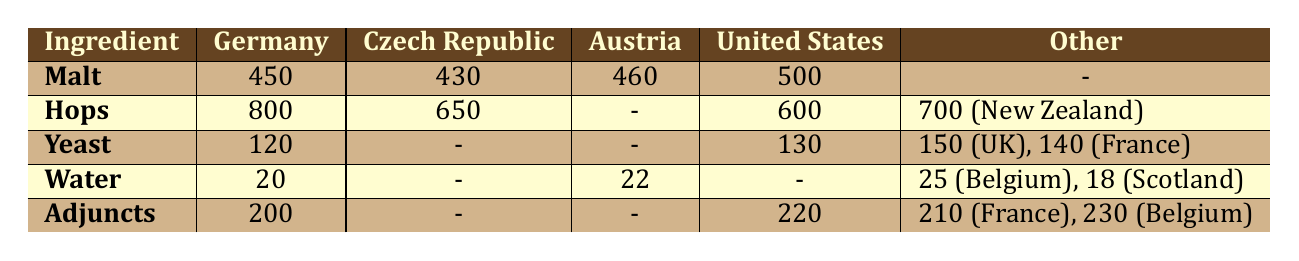What is the sourcing cost of Malt in Germany? The table lists the cost of Malt in Germany as 450. It is directly stated in the "Malt" row under the "Germany" column.
Answer: 450 Which region has the highest cost for Hops? From the Hops row, Germany has the highest sourcing cost among the listed regions, which is 800.
Answer: Germany What is the average cost of Yeast sourced from all regions listed? The costs for Yeast are 120 (Germany), 150 (UK), 130 (US), and 140 (France). Adding these gives a total of 540, and dividing by 4 gives an average cost of 135.
Answer: 135 Is the cost of Water in Scotland lower than in Austria? The cost of Water in Scotland is 18, while in Austria, it is 22. Since 18 is less than 22, the statement is true.
Answer: Yes What is the difference in cost between the most and least expensive Hops? The most expensive Hops cost 800 (Germany) and the least expensive cost 600 (US). Therefore, the difference is 800 - 600 = 200.
Answer: 200 Which ingredient has the lowest sourcing cost in Germany? In Germany, the costs for the ingredients listed are 450 (Malt), 800 (Hops), 120 (Yeast), 20 (Water), and 200 (Adjuncts). The lowest is Water at 20.
Answer: Water How much more expensive is Adjuncts in the United States compared to Germany? The cost of Adjuncts in the US is 220, while in Germany, it is 200. The difference is calculated as 220 - 200, resulting in 20.
Answer: 20 Is the total sourcing cost for Hops higher than that for Malt in Germany? The cost of Hops in Germany is 800 and the cost of Malt is 450. Since 800 is greater than 450, this statement is true.
Answer: Yes If we combine the cost of Barley and Adjuncts in Austria, what is the total? The sourcing cost of Adjuncts is provided as 0 since Barley is not listed in the table, leaving only Adjuncts, which is unlisted; thus, the total is 0.
Answer: 0 